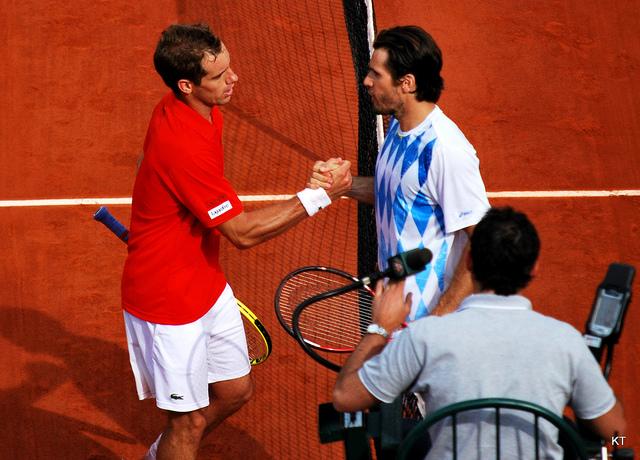Is it traditional for the loser to buy the winner drinks?
Be succinct. No. Are the two men hostile?
Write a very short answer. No. What is the name of the person with the microphone?
Concise answer only. Announcer. Who won the match?
Concise answer only. Man in red. 